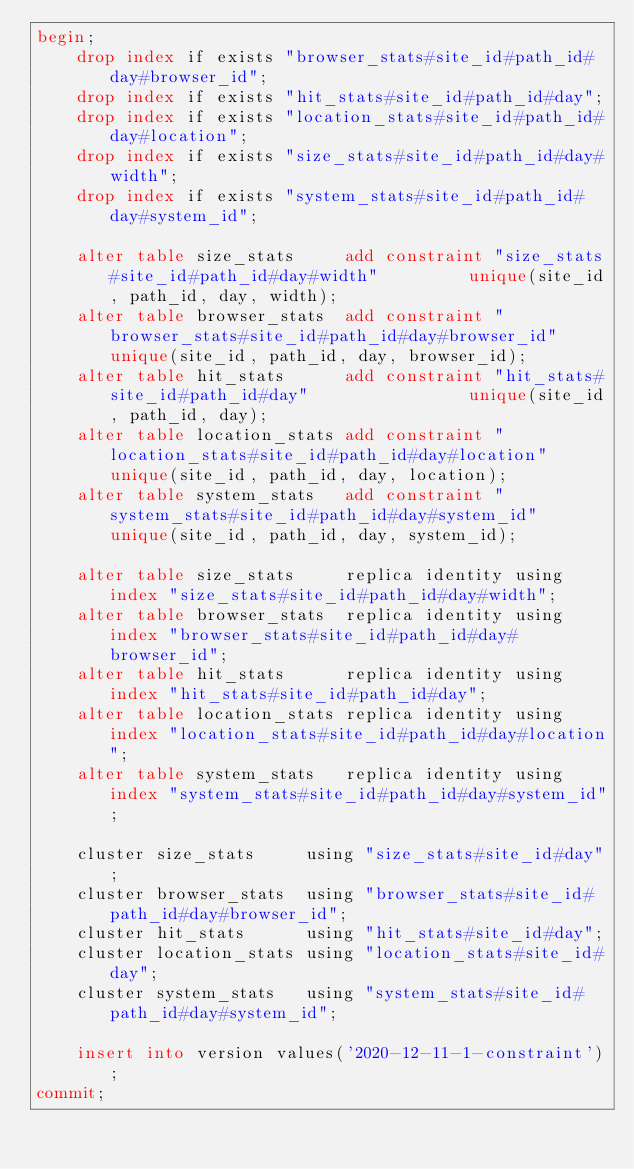Convert code to text. <code><loc_0><loc_0><loc_500><loc_500><_SQL_>begin;
	drop index if exists "browser_stats#site_id#path_id#day#browser_id";
	drop index if exists "hit_stats#site_id#path_id#day";
	drop index if exists "location_stats#site_id#path_id#day#location";
	drop index if exists "size_stats#site_id#path_id#day#width";
	drop index if exists "system_stats#site_id#path_id#day#system_id";

	alter table size_stats     add constraint "size_stats#site_id#path_id#day#width"         unique(site_id, path_id, day, width);
	alter table browser_stats  add constraint "browser_stats#site_id#path_id#day#browser_id" unique(site_id, path_id, day, browser_id);
	alter table hit_stats      add constraint "hit_stats#site_id#path_id#day"                unique(site_id, path_id, day);
	alter table location_stats add constraint "location_stats#site_id#path_id#day#location"  unique(site_id, path_id, day, location);
	alter table system_stats   add constraint "system_stats#site_id#path_id#day#system_id"   unique(site_id, path_id, day, system_id);

	alter table size_stats     replica identity using index "size_stats#site_id#path_id#day#width";
	alter table browser_stats  replica identity using index "browser_stats#site_id#path_id#day#browser_id";
	alter table hit_stats      replica identity using index "hit_stats#site_id#path_id#day";
	alter table location_stats replica identity using index "location_stats#site_id#path_id#day#location";
	alter table system_stats   replica identity using index "system_stats#site_id#path_id#day#system_id";

	cluster size_stats     using "size_stats#site_id#day";
	cluster browser_stats  using "browser_stats#site_id#path_id#day#browser_id";
	cluster hit_stats      using "hit_stats#site_id#day";
	cluster location_stats using "location_stats#site_id#day";
	cluster system_stats   using "system_stats#site_id#path_id#day#system_id";

	insert into version values('2020-12-11-1-constraint');
commit;
</code> 